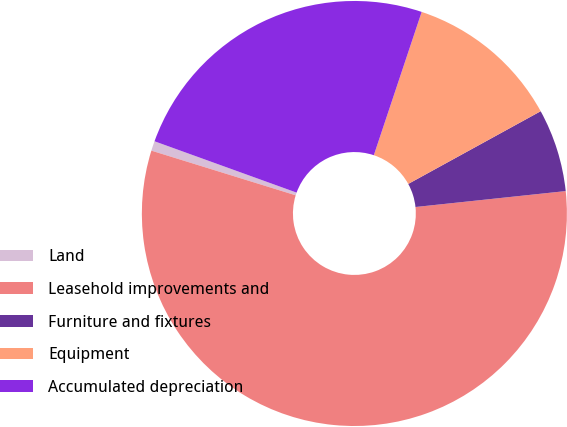Convert chart. <chart><loc_0><loc_0><loc_500><loc_500><pie_chart><fcel>Land<fcel>Leasehold improvements and<fcel>Furniture and fixtures<fcel>Equipment<fcel>Accumulated depreciation<nl><fcel>0.74%<fcel>56.46%<fcel>6.31%<fcel>11.88%<fcel>24.61%<nl></chart> 